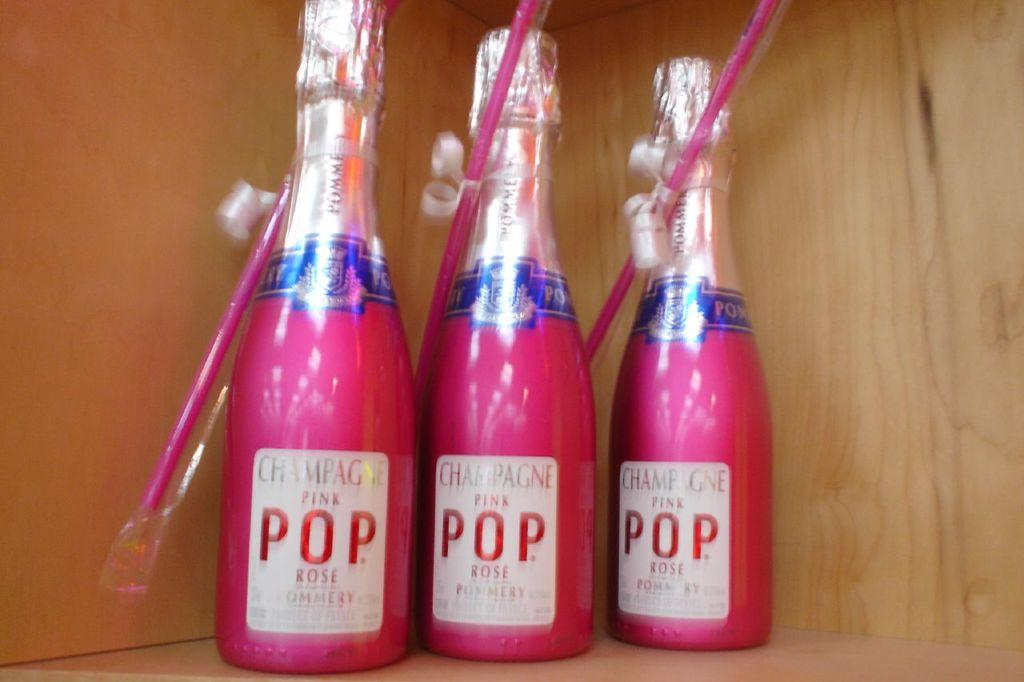Provide a one-sentence caption for the provided image. Three bottles of Champagne Pink Pop sit on a shelf. 